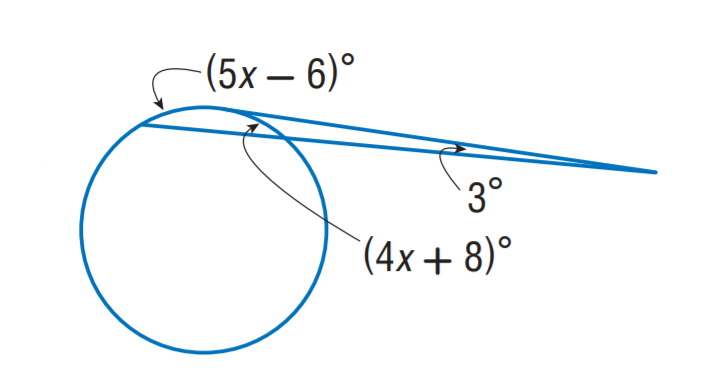Question: Find x.
Choices:
A. 10
B. 15
C. 20
D. 25
Answer with the letter. Answer: C 